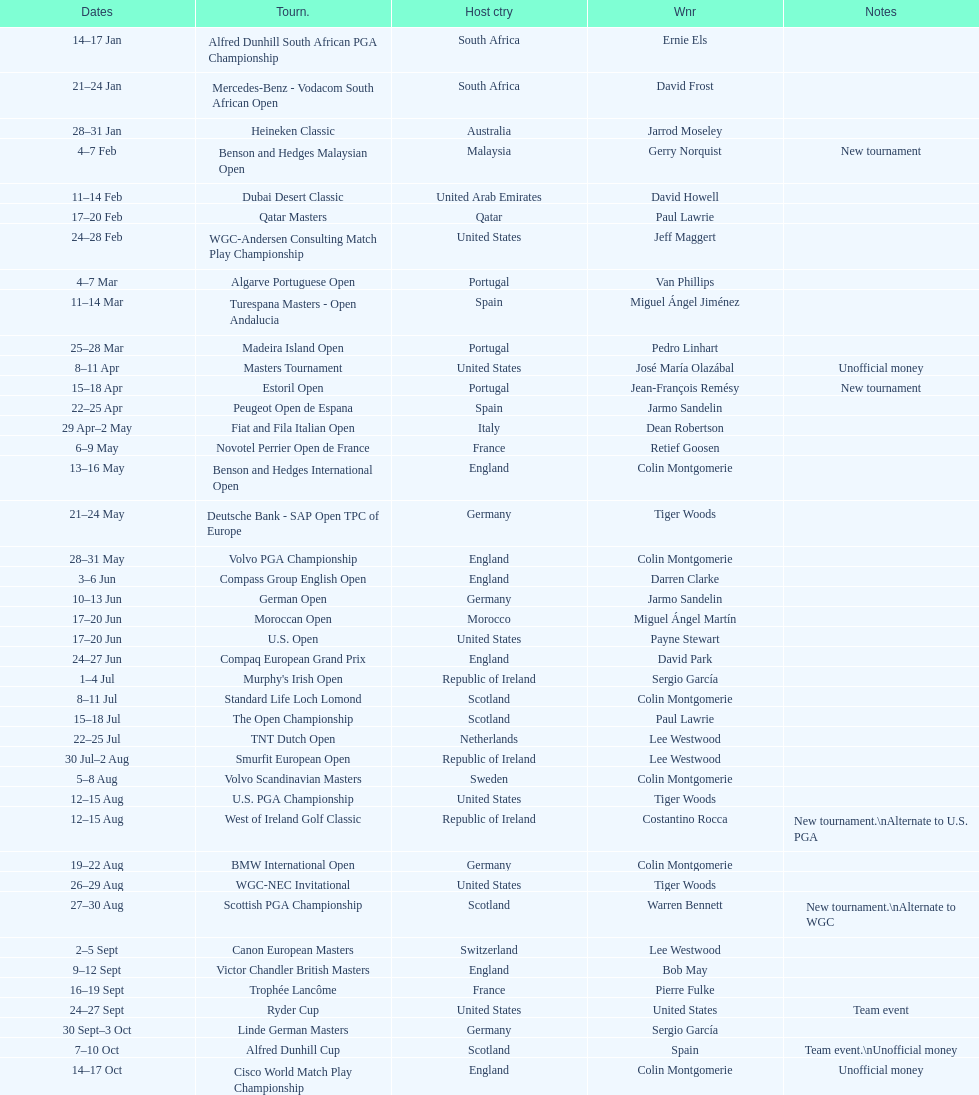Other than qatar masters, name a tournament that was in february. Dubai Desert Classic. 